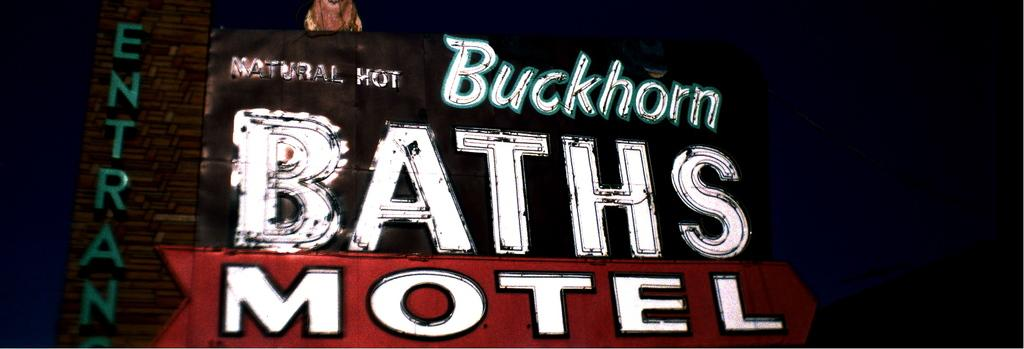<image>
Present a compact description of the photo's key features. An unlit neon sign from Buckhorn Motel with a red arrow pointing toward the entrance. 